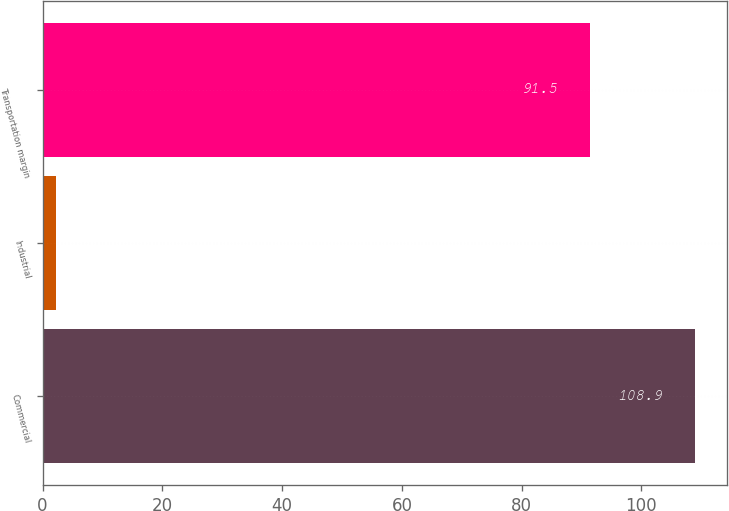Convert chart to OTSL. <chart><loc_0><loc_0><loc_500><loc_500><bar_chart><fcel>Commercial<fcel>Industrial<fcel>Transportation margin<nl><fcel>108.9<fcel>2.2<fcel>91.5<nl></chart> 